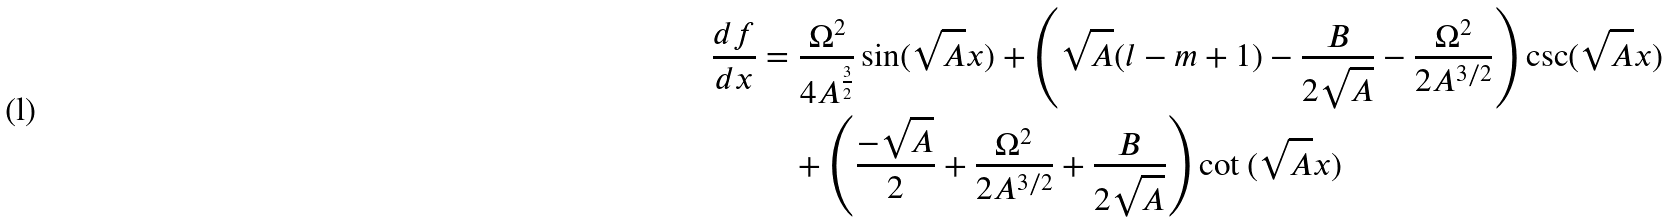<formula> <loc_0><loc_0><loc_500><loc_500>\frac { d f } { d x } & = \frac { \Omega ^ { 2 } } { 4 A ^ { \frac { 3 } { 2 } } } \sin ( { \sqrt { A } x } ) + \left ( \sqrt { A } ( l - m + 1 ) - \frac { B } { 2 \sqrt { A } } - \frac { \Omega ^ { 2 } } { 2 A ^ { 3 / 2 } } \right ) \csc ( \sqrt { A } x ) \\ & \quad + \left ( \frac { - \sqrt { A } } { 2 } + \frac { \Omega ^ { 2 } } { 2 A ^ { { 3 } / { 2 } } } + \frac { B } { 2 \sqrt { A } } \right ) \cot { ( \sqrt { A } x ) }</formula> 